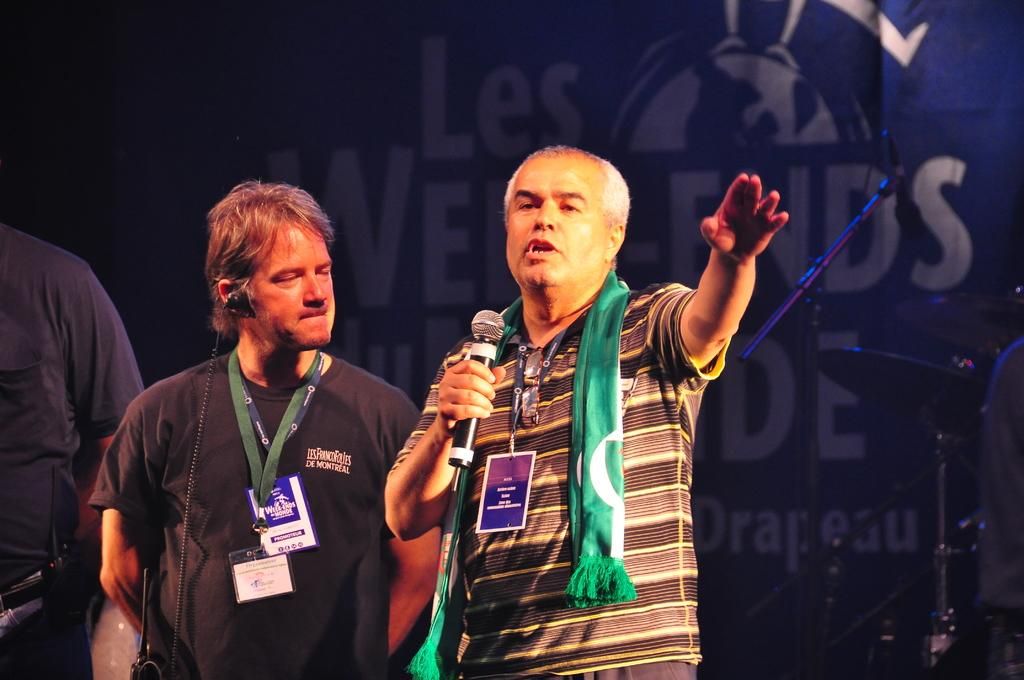How many people are present in the image? There are three people in the image. What is one of the people doing in the image? The first person is speaking. What can be seen hanging or displayed in the image? There is a banner in the image. What is in front of the banner? There are objects in front of the banner. What color is the dress worn by the hydrant in the image? There is no hydrant present in the image, and therefore no dress to describe. 